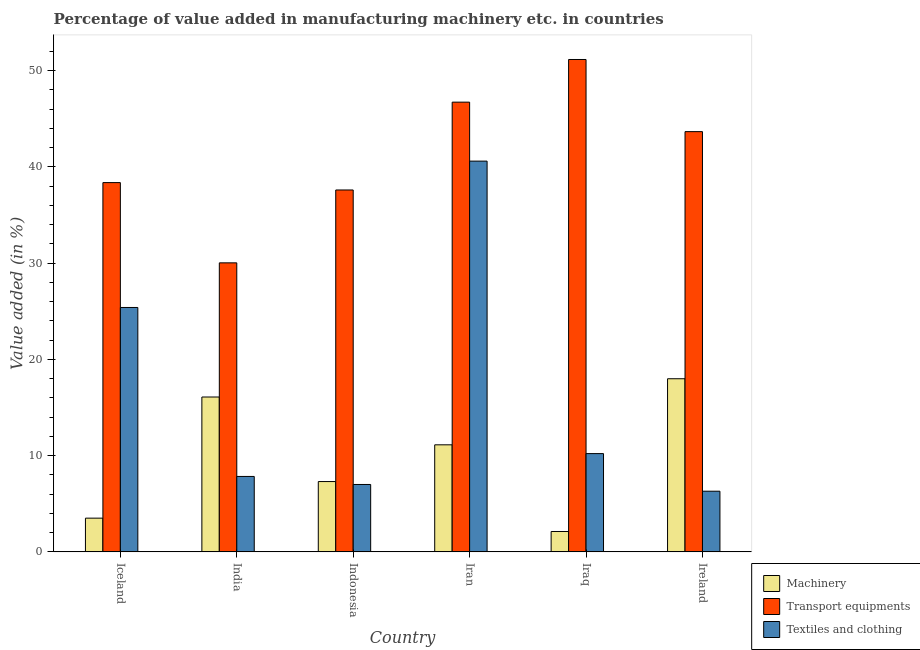How many groups of bars are there?
Give a very brief answer. 6. Are the number of bars per tick equal to the number of legend labels?
Offer a terse response. Yes. What is the label of the 6th group of bars from the left?
Offer a terse response. Ireland. What is the value added in manufacturing textile and clothing in Indonesia?
Your answer should be very brief. 7. Across all countries, what is the maximum value added in manufacturing textile and clothing?
Your answer should be compact. 40.61. Across all countries, what is the minimum value added in manufacturing machinery?
Make the answer very short. 2.12. In which country was the value added in manufacturing textile and clothing maximum?
Your answer should be compact. Iran. In which country was the value added in manufacturing machinery minimum?
Ensure brevity in your answer.  Iraq. What is the total value added in manufacturing machinery in the graph?
Give a very brief answer. 58.14. What is the difference between the value added in manufacturing machinery in India and that in Iraq?
Keep it short and to the point. 13.98. What is the difference between the value added in manufacturing transport equipments in Iceland and the value added in manufacturing textile and clothing in Ireland?
Provide a succinct answer. 32.07. What is the average value added in manufacturing transport equipments per country?
Your answer should be very brief. 41.26. What is the difference between the value added in manufacturing machinery and value added in manufacturing textile and clothing in Indonesia?
Keep it short and to the point. 0.3. What is the ratio of the value added in manufacturing machinery in Iceland to that in Iraq?
Keep it short and to the point. 1.66. What is the difference between the highest and the second highest value added in manufacturing transport equipments?
Your response must be concise. 4.43. What is the difference between the highest and the lowest value added in manufacturing textile and clothing?
Offer a terse response. 34.3. In how many countries, is the value added in manufacturing textile and clothing greater than the average value added in manufacturing textile and clothing taken over all countries?
Provide a succinct answer. 2. Is the sum of the value added in manufacturing textile and clothing in Iran and Ireland greater than the maximum value added in manufacturing transport equipments across all countries?
Ensure brevity in your answer.  No. What does the 2nd bar from the left in Ireland represents?
Provide a short and direct response. Transport equipments. What does the 3rd bar from the right in Indonesia represents?
Make the answer very short. Machinery. Is it the case that in every country, the sum of the value added in manufacturing machinery and value added in manufacturing transport equipments is greater than the value added in manufacturing textile and clothing?
Offer a very short reply. Yes. Are the values on the major ticks of Y-axis written in scientific E-notation?
Your answer should be very brief. No. Does the graph contain grids?
Offer a terse response. No. What is the title of the graph?
Offer a very short reply. Percentage of value added in manufacturing machinery etc. in countries. Does "Ages 15-64" appear as one of the legend labels in the graph?
Offer a very short reply. No. What is the label or title of the Y-axis?
Provide a succinct answer. Value added (in %). What is the Value added (in %) in Machinery in Iceland?
Give a very brief answer. 3.5. What is the Value added (in %) in Transport equipments in Iceland?
Your response must be concise. 38.37. What is the Value added (in %) in Textiles and clothing in Iceland?
Your answer should be compact. 25.4. What is the Value added (in %) in Machinery in India?
Your answer should be compact. 16.09. What is the Value added (in %) in Transport equipments in India?
Keep it short and to the point. 30.03. What is the Value added (in %) in Textiles and clothing in India?
Make the answer very short. 7.84. What is the Value added (in %) of Machinery in Indonesia?
Give a very brief answer. 7.31. What is the Value added (in %) of Transport equipments in Indonesia?
Offer a very short reply. 37.61. What is the Value added (in %) of Textiles and clothing in Indonesia?
Keep it short and to the point. 7. What is the Value added (in %) in Machinery in Iran?
Ensure brevity in your answer.  11.12. What is the Value added (in %) of Transport equipments in Iran?
Offer a very short reply. 46.73. What is the Value added (in %) of Textiles and clothing in Iran?
Your answer should be compact. 40.61. What is the Value added (in %) in Machinery in Iraq?
Offer a very short reply. 2.12. What is the Value added (in %) in Transport equipments in Iraq?
Keep it short and to the point. 51.17. What is the Value added (in %) in Textiles and clothing in Iraq?
Your answer should be compact. 10.21. What is the Value added (in %) in Machinery in Ireland?
Make the answer very short. 17.99. What is the Value added (in %) of Transport equipments in Ireland?
Your answer should be compact. 43.67. What is the Value added (in %) in Textiles and clothing in Ireland?
Your response must be concise. 6.3. Across all countries, what is the maximum Value added (in %) of Machinery?
Ensure brevity in your answer.  17.99. Across all countries, what is the maximum Value added (in %) in Transport equipments?
Provide a short and direct response. 51.17. Across all countries, what is the maximum Value added (in %) in Textiles and clothing?
Give a very brief answer. 40.61. Across all countries, what is the minimum Value added (in %) in Machinery?
Offer a terse response. 2.12. Across all countries, what is the minimum Value added (in %) in Transport equipments?
Ensure brevity in your answer.  30.03. Across all countries, what is the minimum Value added (in %) in Textiles and clothing?
Ensure brevity in your answer.  6.3. What is the total Value added (in %) of Machinery in the graph?
Provide a short and direct response. 58.14. What is the total Value added (in %) in Transport equipments in the graph?
Give a very brief answer. 247.58. What is the total Value added (in %) in Textiles and clothing in the graph?
Your answer should be very brief. 97.36. What is the difference between the Value added (in %) of Machinery in Iceland and that in India?
Provide a short and direct response. -12.59. What is the difference between the Value added (in %) of Transport equipments in Iceland and that in India?
Keep it short and to the point. 8.34. What is the difference between the Value added (in %) in Textiles and clothing in Iceland and that in India?
Provide a short and direct response. 17.56. What is the difference between the Value added (in %) in Machinery in Iceland and that in Indonesia?
Offer a terse response. -3.8. What is the difference between the Value added (in %) of Transport equipments in Iceland and that in Indonesia?
Offer a terse response. 0.77. What is the difference between the Value added (in %) in Textiles and clothing in Iceland and that in Indonesia?
Provide a succinct answer. 18.39. What is the difference between the Value added (in %) of Machinery in Iceland and that in Iran?
Your answer should be compact. -7.62. What is the difference between the Value added (in %) of Transport equipments in Iceland and that in Iran?
Your answer should be very brief. -8.36. What is the difference between the Value added (in %) in Textiles and clothing in Iceland and that in Iran?
Your response must be concise. -15.21. What is the difference between the Value added (in %) of Machinery in Iceland and that in Iraq?
Make the answer very short. 1.39. What is the difference between the Value added (in %) of Transport equipments in Iceland and that in Iraq?
Make the answer very short. -12.79. What is the difference between the Value added (in %) of Textiles and clothing in Iceland and that in Iraq?
Your answer should be very brief. 15.19. What is the difference between the Value added (in %) in Machinery in Iceland and that in Ireland?
Provide a short and direct response. -14.49. What is the difference between the Value added (in %) in Transport equipments in Iceland and that in Ireland?
Make the answer very short. -5.3. What is the difference between the Value added (in %) in Textiles and clothing in Iceland and that in Ireland?
Make the answer very short. 19.09. What is the difference between the Value added (in %) of Machinery in India and that in Indonesia?
Make the answer very short. 8.79. What is the difference between the Value added (in %) in Transport equipments in India and that in Indonesia?
Ensure brevity in your answer.  -7.57. What is the difference between the Value added (in %) in Textiles and clothing in India and that in Indonesia?
Make the answer very short. 0.84. What is the difference between the Value added (in %) of Machinery in India and that in Iran?
Ensure brevity in your answer.  4.97. What is the difference between the Value added (in %) of Transport equipments in India and that in Iran?
Make the answer very short. -16.7. What is the difference between the Value added (in %) in Textiles and clothing in India and that in Iran?
Make the answer very short. -32.77. What is the difference between the Value added (in %) of Machinery in India and that in Iraq?
Your answer should be compact. 13.98. What is the difference between the Value added (in %) of Transport equipments in India and that in Iraq?
Provide a succinct answer. -21.13. What is the difference between the Value added (in %) of Textiles and clothing in India and that in Iraq?
Your response must be concise. -2.37. What is the difference between the Value added (in %) in Machinery in India and that in Ireland?
Offer a terse response. -1.9. What is the difference between the Value added (in %) of Transport equipments in India and that in Ireland?
Provide a short and direct response. -13.64. What is the difference between the Value added (in %) of Textiles and clothing in India and that in Ireland?
Ensure brevity in your answer.  1.53. What is the difference between the Value added (in %) of Machinery in Indonesia and that in Iran?
Keep it short and to the point. -3.82. What is the difference between the Value added (in %) of Transport equipments in Indonesia and that in Iran?
Offer a terse response. -9.13. What is the difference between the Value added (in %) of Textiles and clothing in Indonesia and that in Iran?
Offer a terse response. -33.6. What is the difference between the Value added (in %) of Machinery in Indonesia and that in Iraq?
Offer a very short reply. 5.19. What is the difference between the Value added (in %) in Transport equipments in Indonesia and that in Iraq?
Offer a very short reply. -13.56. What is the difference between the Value added (in %) of Textiles and clothing in Indonesia and that in Iraq?
Your answer should be very brief. -3.21. What is the difference between the Value added (in %) of Machinery in Indonesia and that in Ireland?
Your answer should be very brief. -10.68. What is the difference between the Value added (in %) in Transport equipments in Indonesia and that in Ireland?
Your answer should be very brief. -6.06. What is the difference between the Value added (in %) in Textiles and clothing in Indonesia and that in Ireland?
Make the answer very short. 0.7. What is the difference between the Value added (in %) in Machinery in Iran and that in Iraq?
Your response must be concise. 9.01. What is the difference between the Value added (in %) of Transport equipments in Iran and that in Iraq?
Your response must be concise. -4.43. What is the difference between the Value added (in %) of Textiles and clothing in Iran and that in Iraq?
Ensure brevity in your answer.  30.39. What is the difference between the Value added (in %) in Machinery in Iran and that in Ireland?
Provide a short and direct response. -6.87. What is the difference between the Value added (in %) of Transport equipments in Iran and that in Ireland?
Your response must be concise. 3.06. What is the difference between the Value added (in %) in Textiles and clothing in Iran and that in Ireland?
Keep it short and to the point. 34.3. What is the difference between the Value added (in %) in Machinery in Iraq and that in Ireland?
Provide a succinct answer. -15.87. What is the difference between the Value added (in %) in Transport equipments in Iraq and that in Ireland?
Offer a terse response. 7.5. What is the difference between the Value added (in %) of Textiles and clothing in Iraq and that in Ireland?
Give a very brief answer. 3.91. What is the difference between the Value added (in %) in Machinery in Iceland and the Value added (in %) in Transport equipments in India?
Your answer should be compact. -26.53. What is the difference between the Value added (in %) in Machinery in Iceland and the Value added (in %) in Textiles and clothing in India?
Keep it short and to the point. -4.33. What is the difference between the Value added (in %) of Transport equipments in Iceland and the Value added (in %) of Textiles and clothing in India?
Your answer should be very brief. 30.53. What is the difference between the Value added (in %) of Machinery in Iceland and the Value added (in %) of Transport equipments in Indonesia?
Give a very brief answer. -34.1. What is the difference between the Value added (in %) of Machinery in Iceland and the Value added (in %) of Textiles and clothing in Indonesia?
Make the answer very short. -3.5. What is the difference between the Value added (in %) in Transport equipments in Iceland and the Value added (in %) in Textiles and clothing in Indonesia?
Provide a succinct answer. 31.37. What is the difference between the Value added (in %) of Machinery in Iceland and the Value added (in %) of Transport equipments in Iran?
Your response must be concise. -43.23. What is the difference between the Value added (in %) in Machinery in Iceland and the Value added (in %) in Textiles and clothing in Iran?
Provide a succinct answer. -37.1. What is the difference between the Value added (in %) of Transport equipments in Iceland and the Value added (in %) of Textiles and clothing in Iran?
Ensure brevity in your answer.  -2.23. What is the difference between the Value added (in %) in Machinery in Iceland and the Value added (in %) in Transport equipments in Iraq?
Give a very brief answer. -47.66. What is the difference between the Value added (in %) in Machinery in Iceland and the Value added (in %) in Textiles and clothing in Iraq?
Provide a succinct answer. -6.71. What is the difference between the Value added (in %) of Transport equipments in Iceland and the Value added (in %) of Textiles and clothing in Iraq?
Offer a very short reply. 28.16. What is the difference between the Value added (in %) in Machinery in Iceland and the Value added (in %) in Transport equipments in Ireland?
Keep it short and to the point. -40.16. What is the difference between the Value added (in %) in Machinery in Iceland and the Value added (in %) in Textiles and clothing in Ireland?
Your answer should be very brief. -2.8. What is the difference between the Value added (in %) of Transport equipments in Iceland and the Value added (in %) of Textiles and clothing in Ireland?
Offer a very short reply. 32.07. What is the difference between the Value added (in %) of Machinery in India and the Value added (in %) of Transport equipments in Indonesia?
Your answer should be compact. -21.51. What is the difference between the Value added (in %) of Machinery in India and the Value added (in %) of Textiles and clothing in Indonesia?
Offer a very short reply. 9.09. What is the difference between the Value added (in %) in Transport equipments in India and the Value added (in %) in Textiles and clothing in Indonesia?
Your answer should be very brief. 23.03. What is the difference between the Value added (in %) of Machinery in India and the Value added (in %) of Transport equipments in Iran?
Provide a succinct answer. -30.64. What is the difference between the Value added (in %) of Machinery in India and the Value added (in %) of Textiles and clothing in Iran?
Ensure brevity in your answer.  -24.51. What is the difference between the Value added (in %) of Transport equipments in India and the Value added (in %) of Textiles and clothing in Iran?
Your answer should be very brief. -10.57. What is the difference between the Value added (in %) of Machinery in India and the Value added (in %) of Transport equipments in Iraq?
Provide a succinct answer. -35.07. What is the difference between the Value added (in %) of Machinery in India and the Value added (in %) of Textiles and clothing in Iraq?
Give a very brief answer. 5.88. What is the difference between the Value added (in %) in Transport equipments in India and the Value added (in %) in Textiles and clothing in Iraq?
Offer a terse response. 19.82. What is the difference between the Value added (in %) of Machinery in India and the Value added (in %) of Transport equipments in Ireland?
Ensure brevity in your answer.  -27.58. What is the difference between the Value added (in %) of Machinery in India and the Value added (in %) of Textiles and clothing in Ireland?
Give a very brief answer. 9.79. What is the difference between the Value added (in %) of Transport equipments in India and the Value added (in %) of Textiles and clothing in Ireland?
Offer a terse response. 23.73. What is the difference between the Value added (in %) of Machinery in Indonesia and the Value added (in %) of Transport equipments in Iran?
Offer a very short reply. -39.43. What is the difference between the Value added (in %) of Machinery in Indonesia and the Value added (in %) of Textiles and clothing in Iran?
Offer a very short reply. -33.3. What is the difference between the Value added (in %) in Transport equipments in Indonesia and the Value added (in %) in Textiles and clothing in Iran?
Ensure brevity in your answer.  -3. What is the difference between the Value added (in %) of Machinery in Indonesia and the Value added (in %) of Transport equipments in Iraq?
Provide a short and direct response. -43.86. What is the difference between the Value added (in %) in Machinery in Indonesia and the Value added (in %) in Textiles and clothing in Iraq?
Your answer should be compact. -2.91. What is the difference between the Value added (in %) of Transport equipments in Indonesia and the Value added (in %) of Textiles and clothing in Iraq?
Make the answer very short. 27.39. What is the difference between the Value added (in %) in Machinery in Indonesia and the Value added (in %) in Transport equipments in Ireland?
Offer a very short reply. -36.36. What is the difference between the Value added (in %) in Transport equipments in Indonesia and the Value added (in %) in Textiles and clothing in Ireland?
Offer a very short reply. 31.3. What is the difference between the Value added (in %) in Machinery in Iran and the Value added (in %) in Transport equipments in Iraq?
Make the answer very short. -40.04. What is the difference between the Value added (in %) in Machinery in Iran and the Value added (in %) in Textiles and clothing in Iraq?
Offer a very short reply. 0.91. What is the difference between the Value added (in %) of Transport equipments in Iran and the Value added (in %) of Textiles and clothing in Iraq?
Your response must be concise. 36.52. What is the difference between the Value added (in %) of Machinery in Iran and the Value added (in %) of Transport equipments in Ireland?
Your answer should be very brief. -32.54. What is the difference between the Value added (in %) in Machinery in Iran and the Value added (in %) in Textiles and clothing in Ireland?
Provide a succinct answer. 4.82. What is the difference between the Value added (in %) in Transport equipments in Iran and the Value added (in %) in Textiles and clothing in Ireland?
Provide a short and direct response. 40.43. What is the difference between the Value added (in %) of Machinery in Iraq and the Value added (in %) of Transport equipments in Ireland?
Ensure brevity in your answer.  -41.55. What is the difference between the Value added (in %) of Machinery in Iraq and the Value added (in %) of Textiles and clothing in Ireland?
Provide a short and direct response. -4.19. What is the difference between the Value added (in %) in Transport equipments in Iraq and the Value added (in %) in Textiles and clothing in Ireland?
Offer a very short reply. 44.86. What is the average Value added (in %) in Machinery per country?
Provide a succinct answer. 9.69. What is the average Value added (in %) in Transport equipments per country?
Keep it short and to the point. 41.26. What is the average Value added (in %) of Textiles and clothing per country?
Your answer should be very brief. 16.23. What is the difference between the Value added (in %) in Machinery and Value added (in %) in Transport equipments in Iceland?
Provide a succinct answer. -34.87. What is the difference between the Value added (in %) of Machinery and Value added (in %) of Textiles and clothing in Iceland?
Provide a short and direct response. -21.89. What is the difference between the Value added (in %) in Transport equipments and Value added (in %) in Textiles and clothing in Iceland?
Your answer should be compact. 12.98. What is the difference between the Value added (in %) in Machinery and Value added (in %) in Transport equipments in India?
Make the answer very short. -13.94. What is the difference between the Value added (in %) in Machinery and Value added (in %) in Textiles and clothing in India?
Make the answer very short. 8.25. What is the difference between the Value added (in %) in Transport equipments and Value added (in %) in Textiles and clothing in India?
Provide a short and direct response. 22.2. What is the difference between the Value added (in %) in Machinery and Value added (in %) in Transport equipments in Indonesia?
Give a very brief answer. -30.3. What is the difference between the Value added (in %) in Machinery and Value added (in %) in Textiles and clothing in Indonesia?
Provide a succinct answer. 0.3. What is the difference between the Value added (in %) in Transport equipments and Value added (in %) in Textiles and clothing in Indonesia?
Your answer should be compact. 30.6. What is the difference between the Value added (in %) in Machinery and Value added (in %) in Transport equipments in Iran?
Keep it short and to the point. -35.61. What is the difference between the Value added (in %) in Machinery and Value added (in %) in Textiles and clothing in Iran?
Keep it short and to the point. -29.48. What is the difference between the Value added (in %) in Transport equipments and Value added (in %) in Textiles and clothing in Iran?
Your answer should be compact. 6.13. What is the difference between the Value added (in %) of Machinery and Value added (in %) of Transport equipments in Iraq?
Your answer should be very brief. -49.05. What is the difference between the Value added (in %) of Machinery and Value added (in %) of Textiles and clothing in Iraq?
Ensure brevity in your answer.  -8.09. What is the difference between the Value added (in %) of Transport equipments and Value added (in %) of Textiles and clothing in Iraq?
Provide a succinct answer. 40.95. What is the difference between the Value added (in %) in Machinery and Value added (in %) in Transport equipments in Ireland?
Give a very brief answer. -25.68. What is the difference between the Value added (in %) of Machinery and Value added (in %) of Textiles and clothing in Ireland?
Offer a terse response. 11.69. What is the difference between the Value added (in %) of Transport equipments and Value added (in %) of Textiles and clothing in Ireland?
Provide a short and direct response. 37.37. What is the ratio of the Value added (in %) in Machinery in Iceland to that in India?
Offer a terse response. 0.22. What is the ratio of the Value added (in %) of Transport equipments in Iceland to that in India?
Offer a very short reply. 1.28. What is the ratio of the Value added (in %) in Textiles and clothing in Iceland to that in India?
Give a very brief answer. 3.24. What is the ratio of the Value added (in %) of Machinery in Iceland to that in Indonesia?
Make the answer very short. 0.48. What is the ratio of the Value added (in %) of Transport equipments in Iceland to that in Indonesia?
Provide a short and direct response. 1.02. What is the ratio of the Value added (in %) of Textiles and clothing in Iceland to that in Indonesia?
Make the answer very short. 3.63. What is the ratio of the Value added (in %) of Machinery in Iceland to that in Iran?
Keep it short and to the point. 0.32. What is the ratio of the Value added (in %) in Transport equipments in Iceland to that in Iran?
Ensure brevity in your answer.  0.82. What is the ratio of the Value added (in %) of Textiles and clothing in Iceland to that in Iran?
Offer a terse response. 0.63. What is the ratio of the Value added (in %) in Machinery in Iceland to that in Iraq?
Offer a very short reply. 1.66. What is the ratio of the Value added (in %) in Transport equipments in Iceland to that in Iraq?
Your response must be concise. 0.75. What is the ratio of the Value added (in %) of Textiles and clothing in Iceland to that in Iraq?
Your answer should be very brief. 2.49. What is the ratio of the Value added (in %) in Machinery in Iceland to that in Ireland?
Your answer should be compact. 0.19. What is the ratio of the Value added (in %) in Transport equipments in Iceland to that in Ireland?
Provide a short and direct response. 0.88. What is the ratio of the Value added (in %) of Textiles and clothing in Iceland to that in Ireland?
Your answer should be very brief. 4.03. What is the ratio of the Value added (in %) in Machinery in India to that in Indonesia?
Provide a short and direct response. 2.2. What is the ratio of the Value added (in %) in Transport equipments in India to that in Indonesia?
Provide a succinct answer. 0.8. What is the ratio of the Value added (in %) of Textiles and clothing in India to that in Indonesia?
Provide a short and direct response. 1.12. What is the ratio of the Value added (in %) in Machinery in India to that in Iran?
Make the answer very short. 1.45. What is the ratio of the Value added (in %) of Transport equipments in India to that in Iran?
Provide a short and direct response. 0.64. What is the ratio of the Value added (in %) in Textiles and clothing in India to that in Iran?
Make the answer very short. 0.19. What is the ratio of the Value added (in %) of Machinery in India to that in Iraq?
Ensure brevity in your answer.  7.6. What is the ratio of the Value added (in %) in Transport equipments in India to that in Iraq?
Provide a short and direct response. 0.59. What is the ratio of the Value added (in %) of Textiles and clothing in India to that in Iraq?
Provide a succinct answer. 0.77. What is the ratio of the Value added (in %) of Machinery in India to that in Ireland?
Your response must be concise. 0.89. What is the ratio of the Value added (in %) in Transport equipments in India to that in Ireland?
Your answer should be very brief. 0.69. What is the ratio of the Value added (in %) in Textiles and clothing in India to that in Ireland?
Ensure brevity in your answer.  1.24. What is the ratio of the Value added (in %) of Machinery in Indonesia to that in Iran?
Ensure brevity in your answer.  0.66. What is the ratio of the Value added (in %) of Transport equipments in Indonesia to that in Iran?
Provide a short and direct response. 0.8. What is the ratio of the Value added (in %) of Textiles and clothing in Indonesia to that in Iran?
Your answer should be compact. 0.17. What is the ratio of the Value added (in %) of Machinery in Indonesia to that in Iraq?
Provide a short and direct response. 3.45. What is the ratio of the Value added (in %) in Transport equipments in Indonesia to that in Iraq?
Ensure brevity in your answer.  0.73. What is the ratio of the Value added (in %) of Textiles and clothing in Indonesia to that in Iraq?
Provide a short and direct response. 0.69. What is the ratio of the Value added (in %) in Machinery in Indonesia to that in Ireland?
Your answer should be very brief. 0.41. What is the ratio of the Value added (in %) of Transport equipments in Indonesia to that in Ireland?
Provide a succinct answer. 0.86. What is the ratio of the Value added (in %) of Textiles and clothing in Indonesia to that in Ireland?
Provide a short and direct response. 1.11. What is the ratio of the Value added (in %) of Machinery in Iran to that in Iraq?
Offer a terse response. 5.25. What is the ratio of the Value added (in %) of Transport equipments in Iran to that in Iraq?
Your answer should be compact. 0.91. What is the ratio of the Value added (in %) of Textiles and clothing in Iran to that in Iraq?
Your answer should be very brief. 3.98. What is the ratio of the Value added (in %) of Machinery in Iran to that in Ireland?
Offer a very short reply. 0.62. What is the ratio of the Value added (in %) in Transport equipments in Iran to that in Ireland?
Your answer should be very brief. 1.07. What is the ratio of the Value added (in %) of Textiles and clothing in Iran to that in Ireland?
Ensure brevity in your answer.  6.44. What is the ratio of the Value added (in %) of Machinery in Iraq to that in Ireland?
Offer a very short reply. 0.12. What is the ratio of the Value added (in %) of Transport equipments in Iraq to that in Ireland?
Give a very brief answer. 1.17. What is the ratio of the Value added (in %) of Textiles and clothing in Iraq to that in Ireland?
Keep it short and to the point. 1.62. What is the difference between the highest and the second highest Value added (in %) in Machinery?
Provide a succinct answer. 1.9. What is the difference between the highest and the second highest Value added (in %) in Transport equipments?
Keep it short and to the point. 4.43. What is the difference between the highest and the second highest Value added (in %) in Textiles and clothing?
Offer a terse response. 15.21. What is the difference between the highest and the lowest Value added (in %) of Machinery?
Offer a very short reply. 15.87. What is the difference between the highest and the lowest Value added (in %) of Transport equipments?
Offer a very short reply. 21.13. What is the difference between the highest and the lowest Value added (in %) in Textiles and clothing?
Keep it short and to the point. 34.3. 